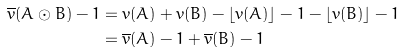Convert formula to latex. <formula><loc_0><loc_0><loc_500><loc_500>\overline { v } ( A \odot B ) - 1 & = v ( A ) + v ( B ) - \lfloor v ( A ) \rfloor - 1 - \lfloor v ( B ) \rfloor - 1 \\ & = \overline { v } ( A ) - 1 + \overline { v } ( B ) - 1</formula> 